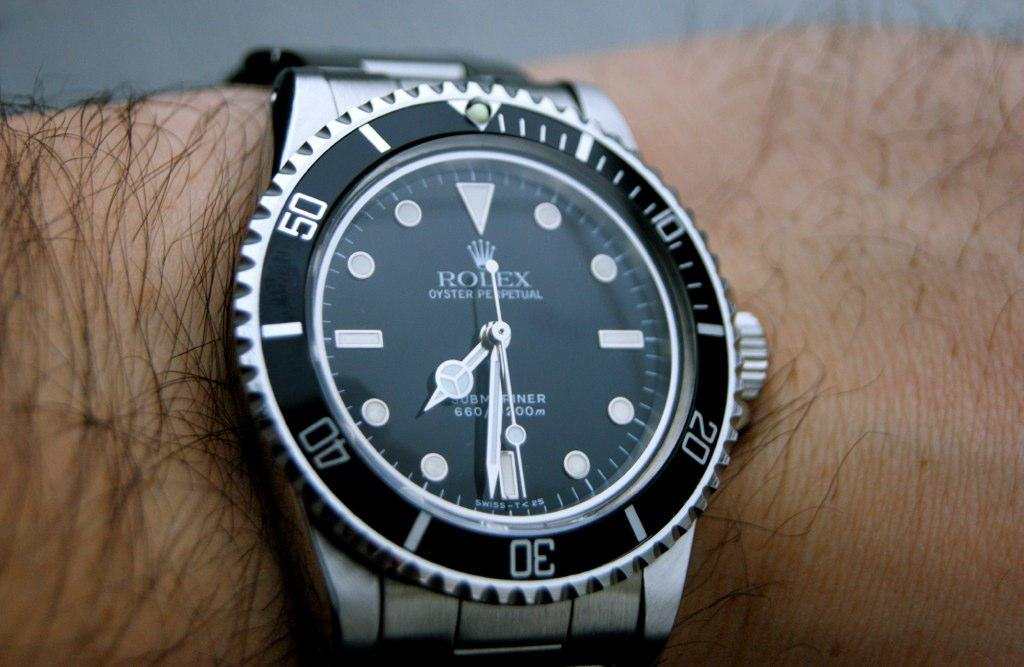What part of a person's body can be seen in the image? A person's hand is visible in the image. What accessory is the person wearing on their hand? The person is wearing a watch. What type of fowl can be seen in the image? There is no fowl present in the image; it only features a person's hand and a watch. What agreement is being made in the image? There is no indication of an agreement being made in the image. 